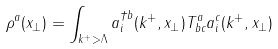Convert formula to latex. <formula><loc_0><loc_0><loc_500><loc_500>\rho ^ { a } ( x _ { \perp } ) = \int _ { k ^ { + } > \Lambda } a ^ { \dagger b } _ { i } ( k ^ { + } , x _ { \perp } ) T ^ { a } _ { b c } a ^ { c } _ { i } ( k ^ { + } , x _ { \perp } )</formula> 